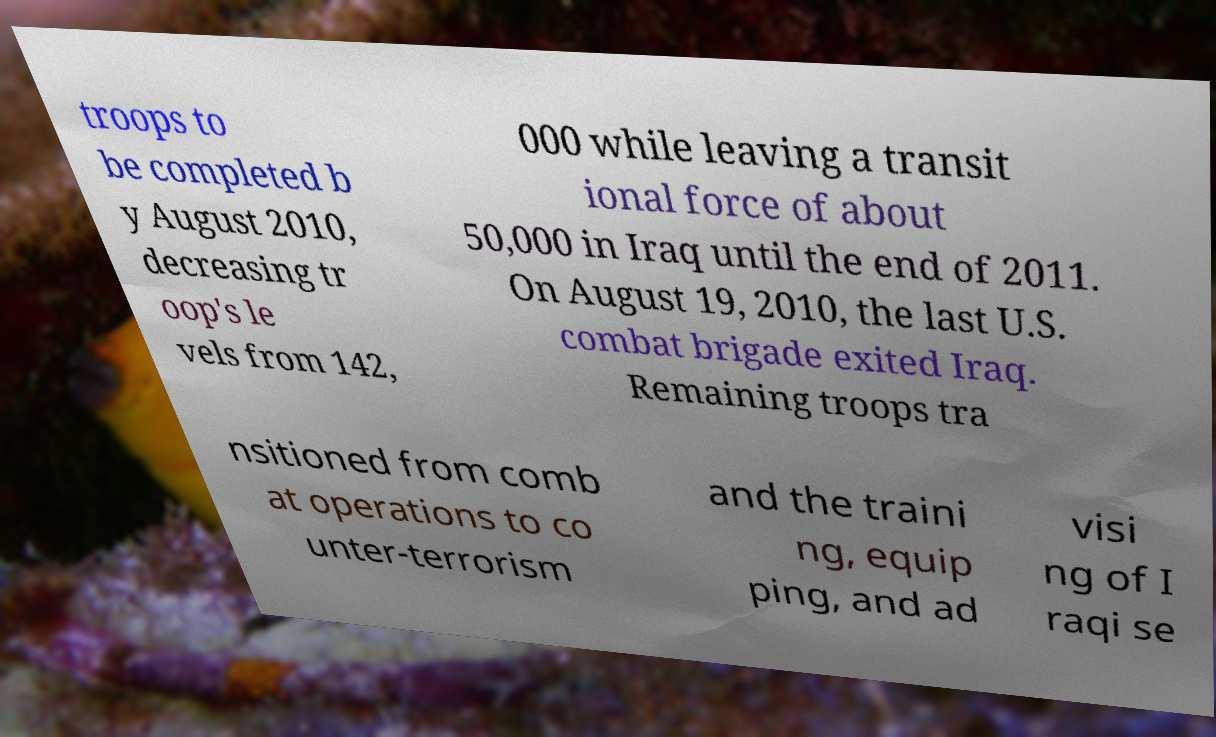Could you assist in decoding the text presented in this image and type it out clearly? troops to be completed b y August 2010, decreasing tr oop's le vels from 142, 000 while leaving a transit ional force of about 50,000 in Iraq until the end of 2011. On August 19, 2010, the last U.S. combat brigade exited Iraq. Remaining troops tra nsitioned from comb at operations to co unter-terrorism and the traini ng, equip ping, and ad visi ng of I raqi se 